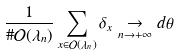<formula> <loc_0><loc_0><loc_500><loc_500>\frac { 1 } { \# \mathcal { O } ( \lambda _ { n } ) } \sum _ { x \in \mathcal { O } ( \lambda _ { n } ) } \delta _ { x } \underset { n \rightarrow + \infty } { \rightarrow } d \theta</formula> 